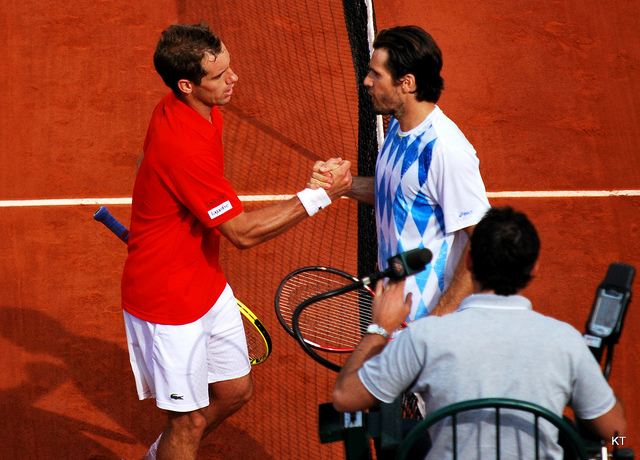<image>What is the name of the person with the microphone? It is unknown. The person with the microphone might be an announcer, referee, reporter, umpire or named Fred. What is the name of the person with the microphone? I don't know the name of the person with the microphone. He can be the announcer, referee, reporter or umpire. 